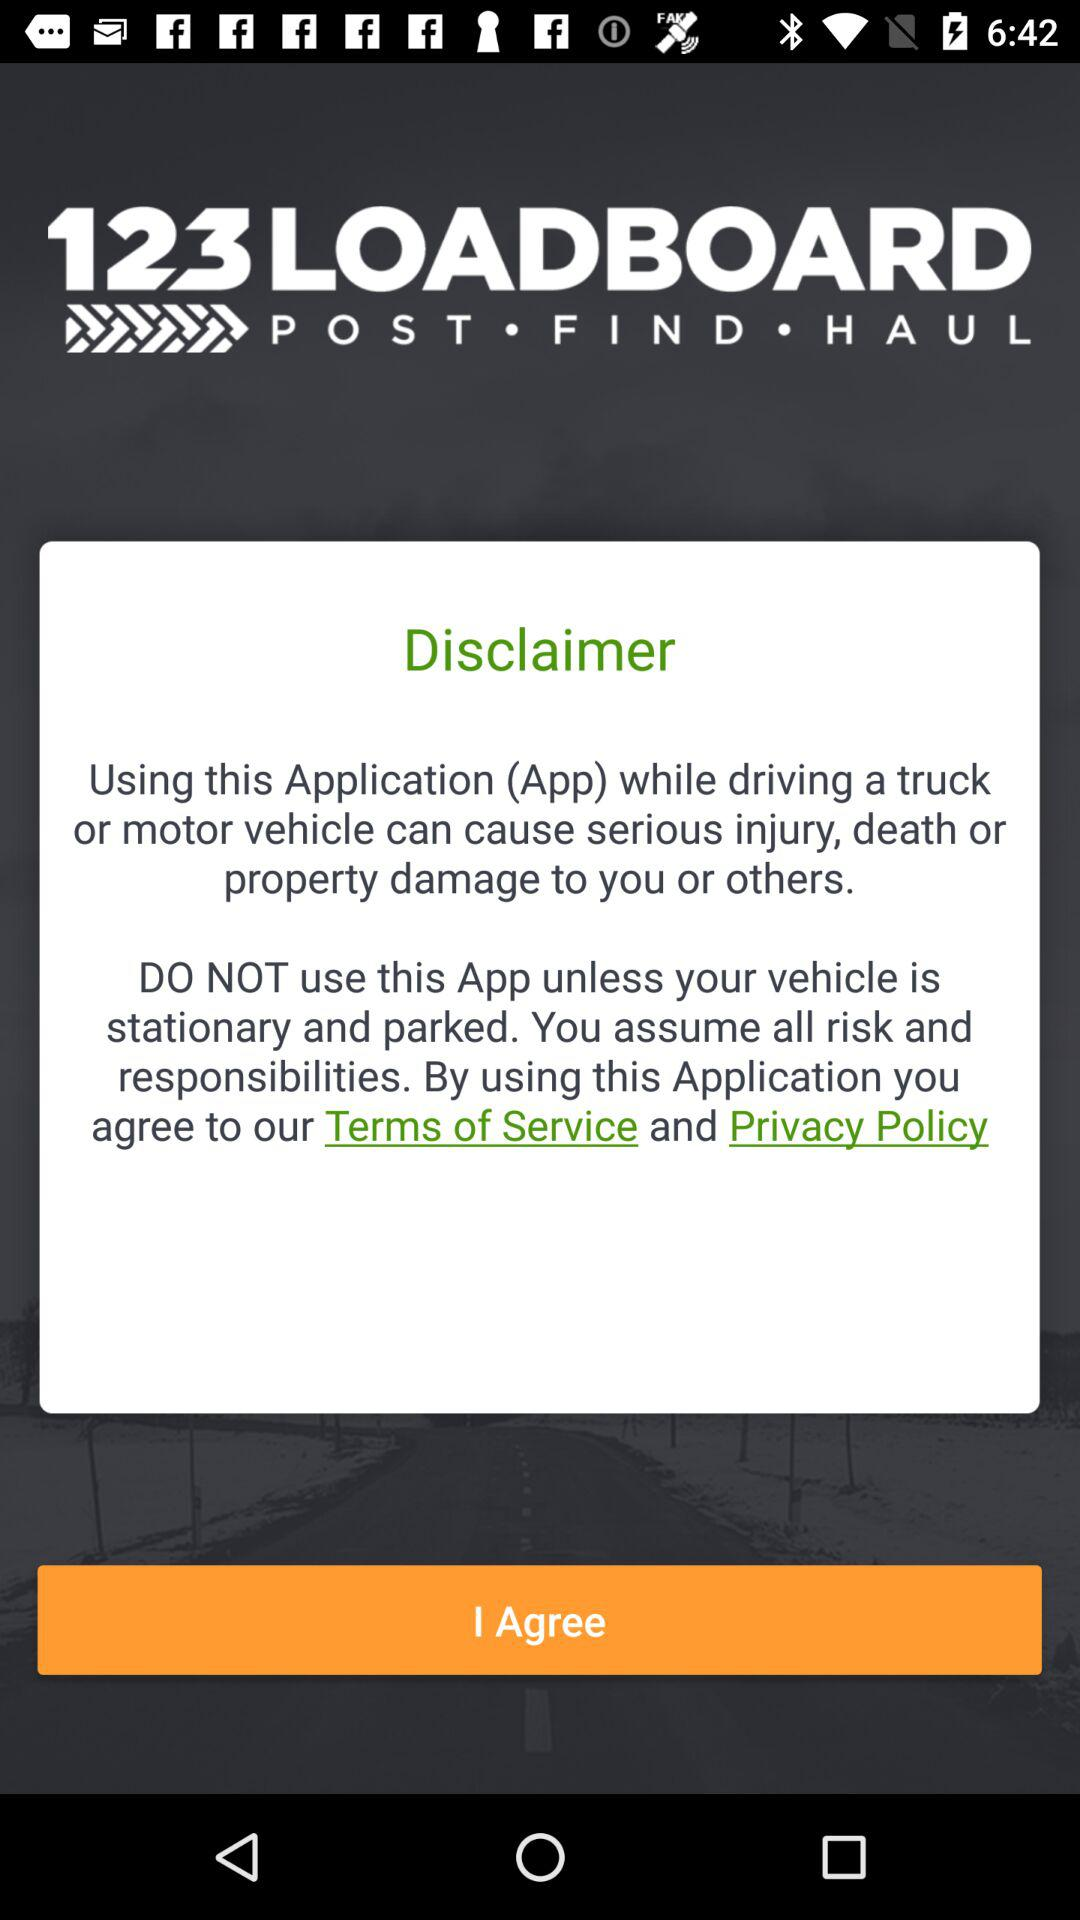Has the user agreed to the terms of service and privacy policy?
When the provided information is insufficient, respond with <no answer>. <no answer> 